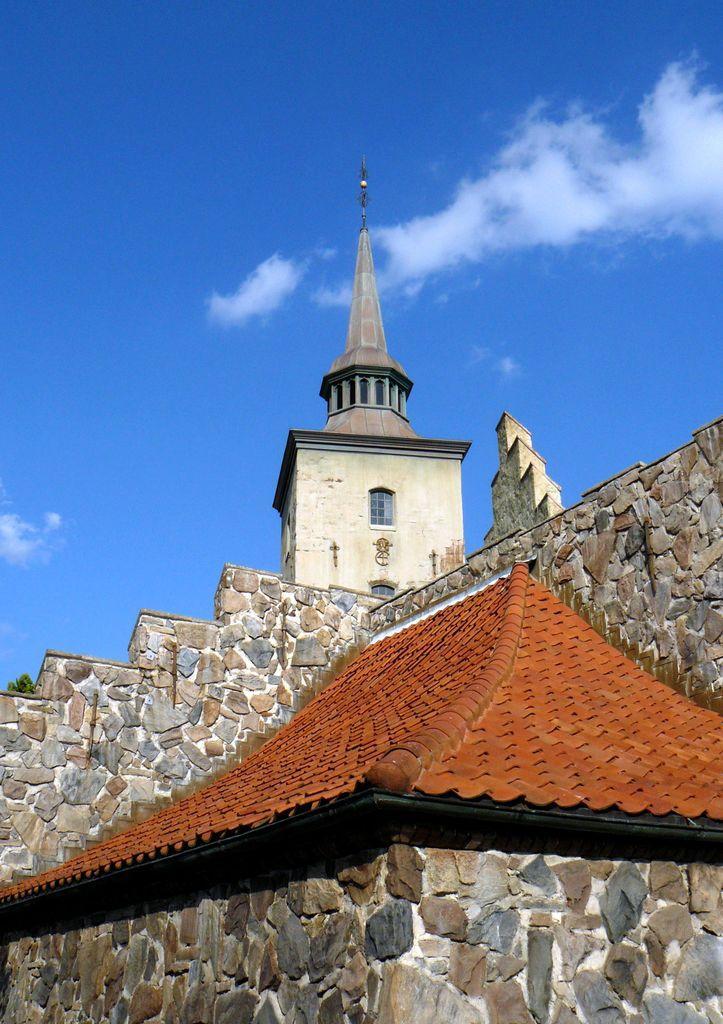How would you summarize this image in a sentence or two? In this image I can see a building in brown and cream color. Background I can see the sky in blue and white color. 